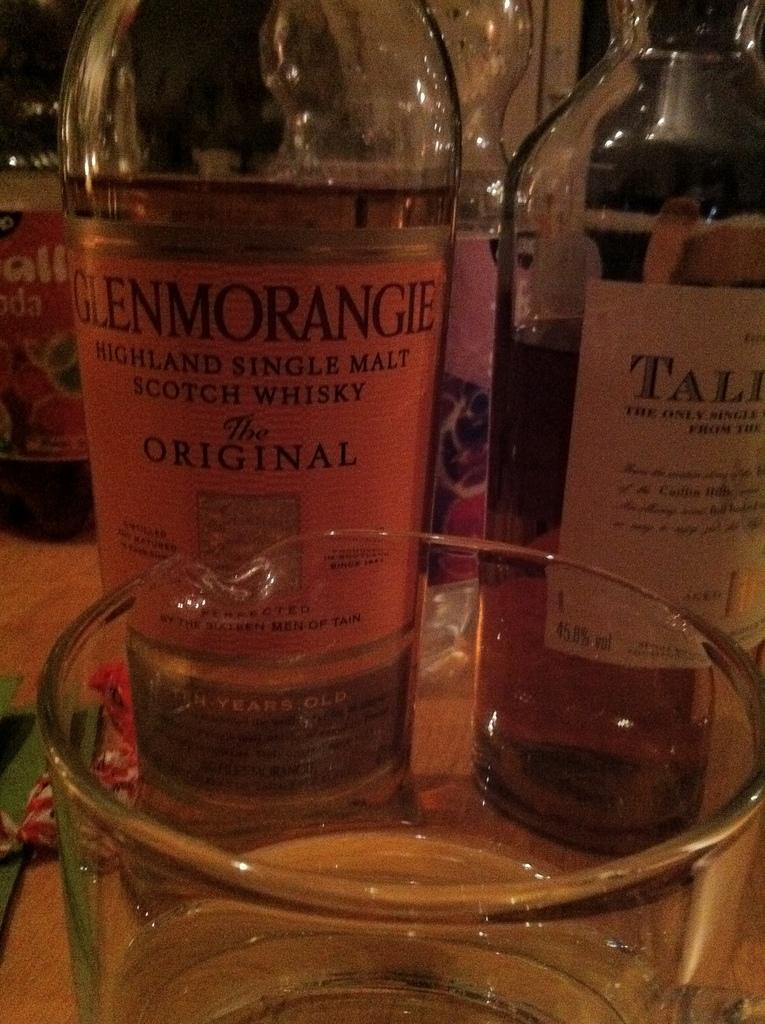<image>
Summarize the visual content of the image. Glass filled with malt liquor on a table with malt liquor bottles. 